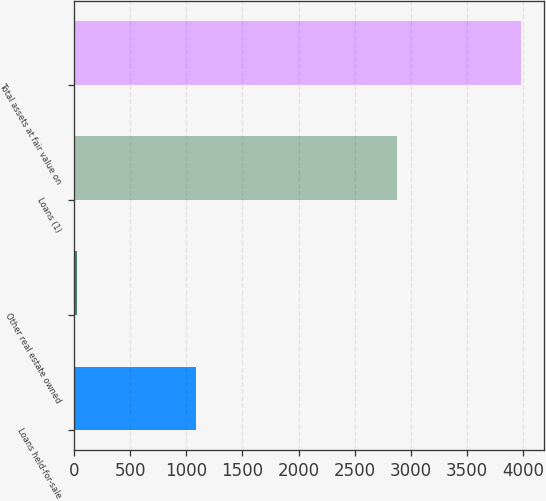Convert chart. <chart><loc_0><loc_0><loc_500><loc_500><bar_chart><fcel>Loans held-for-sale<fcel>Other real estate owned<fcel>Loans (1)<fcel>Total assets at fair value on<nl><fcel>1084<fcel>21<fcel>2881<fcel>3986<nl></chart> 